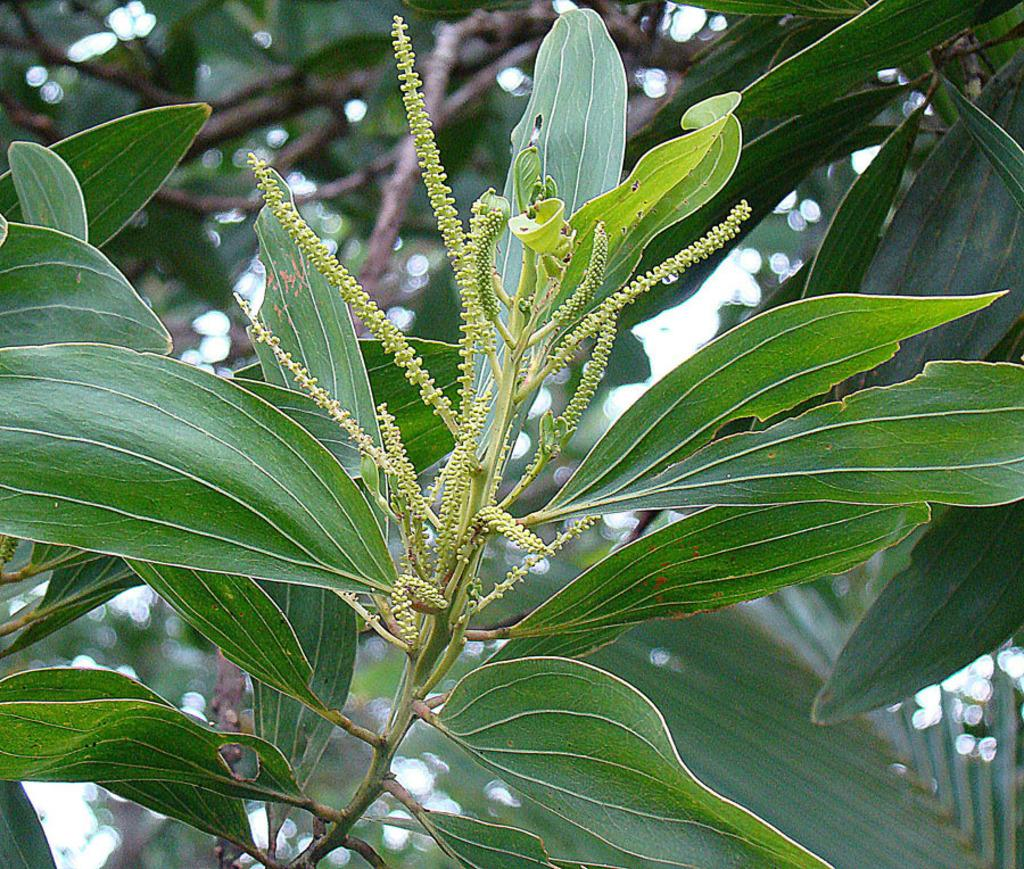What type of clothing item is present in the image? There is a pant in the image. What color is the pant? The pant is green in color. What month is depicted on the pant in the image? There is no month depicted on the pant in the image, as it is a green pant without any specific design or pattern. 